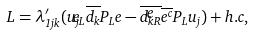<formula> <loc_0><loc_0><loc_500><loc_500>L = \lambda ^ { \prime } _ { 1 j k } ( { \widetilde { u _ { j L } } } { \overline { d _ { k } } } P _ { L } e - { \overline { \widetilde { d _ { k R } } } } \overline { e ^ { c } } P _ { L } u _ { j } ) + h . c ,</formula> 